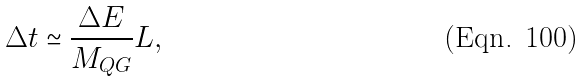<formula> <loc_0><loc_0><loc_500><loc_500>\Delta t \simeq \frac { \Delta E } { M _ { Q G } } L ,</formula> 